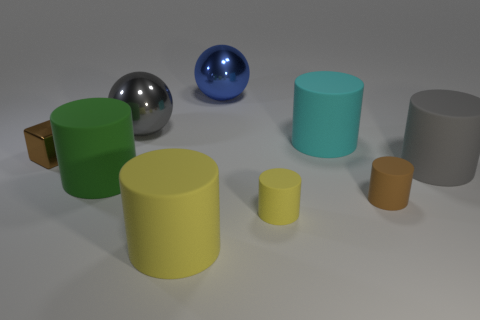Subtract all green cylinders. How many cylinders are left? 5 Subtract all brown cylinders. How many cylinders are left? 5 Subtract all cyan cylinders. Subtract all purple cubes. How many cylinders are left? 5 Add 1 small brown cylinders. How many objects exist? 10 Subtract all spheres. How many objects are left? 7 Subtract all big matte cylinders. Subtract all big rubber cylinders. How many objects are left? 1 Add 1 tiny brown cubes. How many tiny brown cubes are left? 2 Add 5 large rubber things. How many large rubber things exist? 9 Subtract 1 brown blocks. How many objects are left? 8 